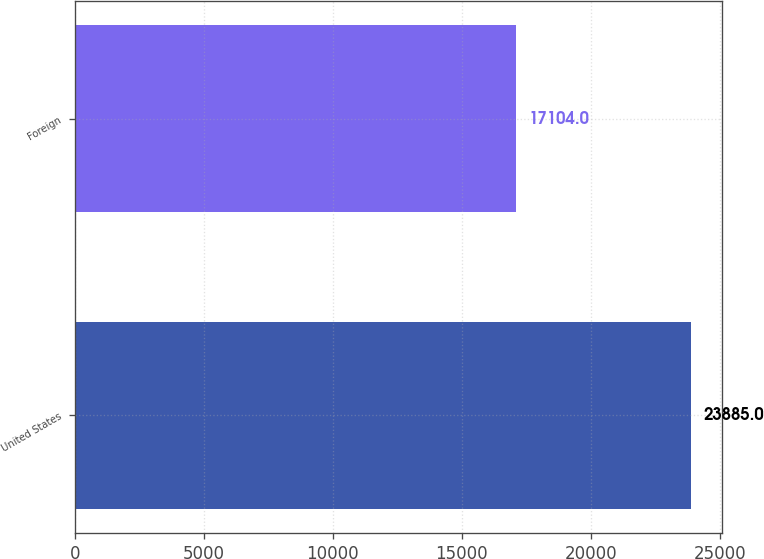Convert chart to OTSL. <chart><loc_0><loc_0><loc_500><loc_500><bar_chart><fcel>United States<fcel>Foreign<nl><fcel>23885<fcel>17104<nl></chart> 